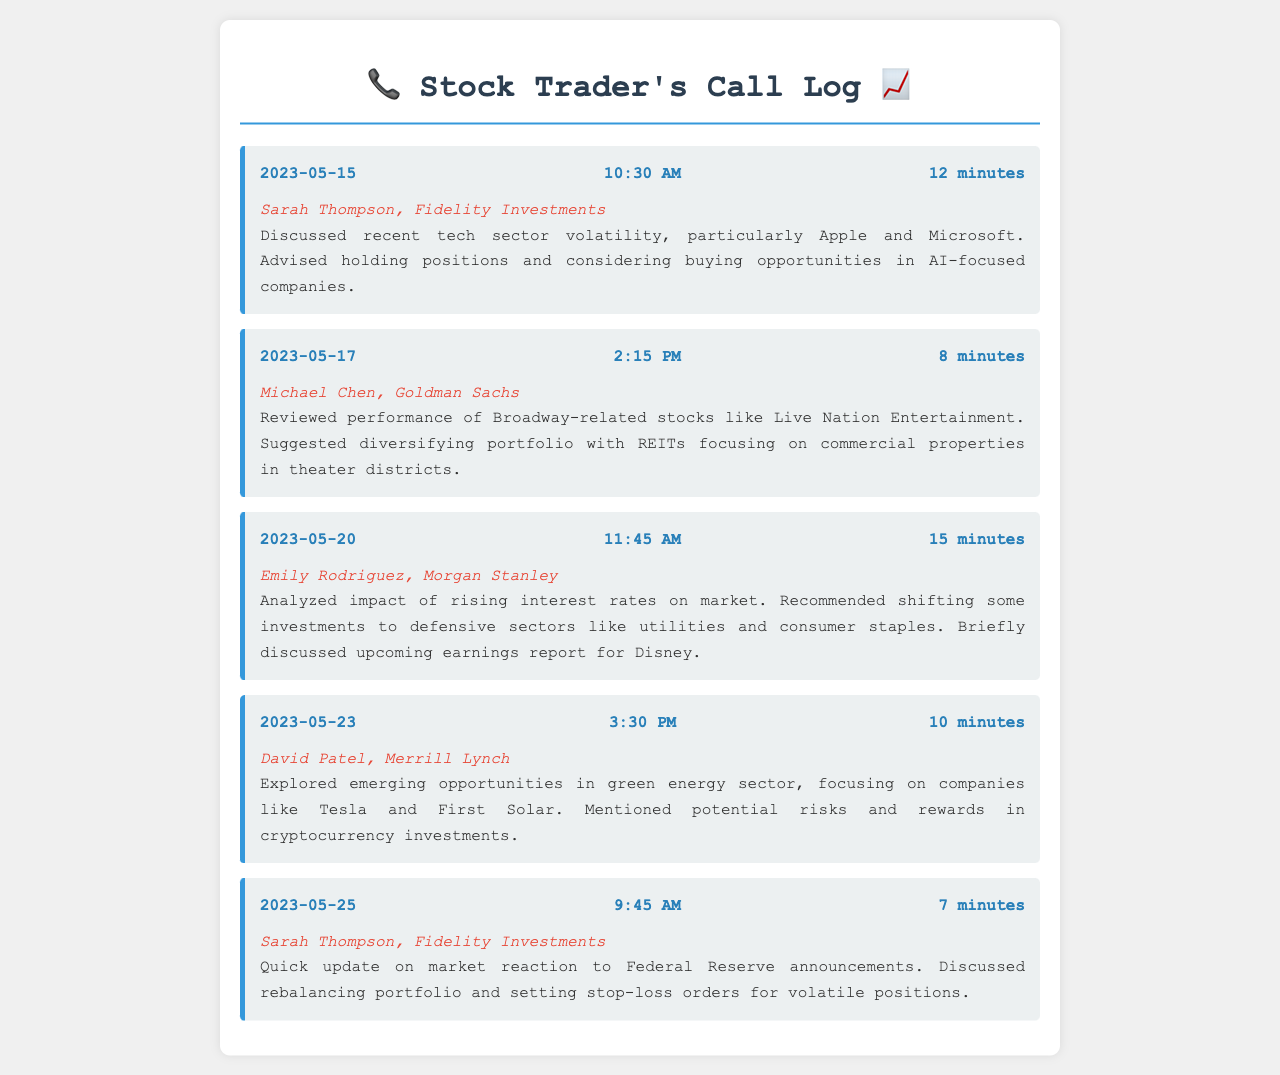What is the date of the first call? The first call in the log is dated 2023-05-15.
Answer: 2023-05-15 Who is the stockbroker for the last call? The last call in the log is with Sarah Thompson from Fidelity Investments.
Answer: Sarah Thompson, Fidelity Investments What was discussed during the call on May 20? The call on May 20 analyzed the impact of rising interest rates and recommended shifting investments to defensive sectors.
Answer: Rising interest rates and defensive sectors How long was the call with Michael Chen? The call with Michael Chen lasted for 8 minutes.
Answer: 8 minutes Which company was mentioned in relation to the earnings report? The earnings report discussed during the call was for Disney.
Answer: Disney What sector was recommended for investment by David Patel? David Patel explored emerging opportunities in the green energy sector.
Answer: Green energy How many calls were made in total? There are five calls recorded in the log.
Answer: Five What specific type of stocks did Michael Chen suggest diversifying with? Michael Chen suggested diversifying with REITs focused on commercial properties.
Answer: REITs What did Sarah Thompson recommend doing with volatile positions? Sarah Thompson recommended setting stop-loss orders for volatile positions.
Answer: Setting stop-loss orders 